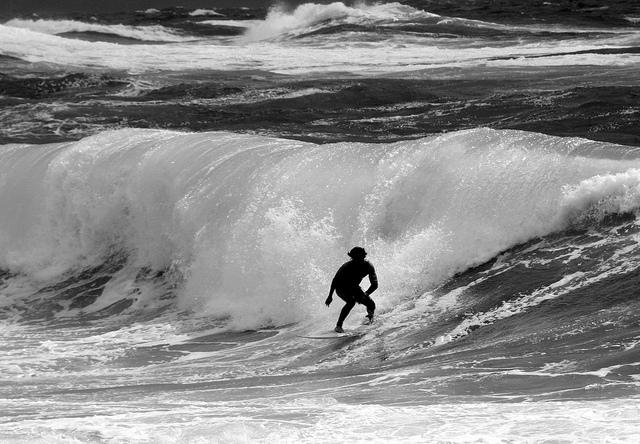How high are the waves?
Short answer required. 12 feet. Can you tell is this is a man or woman?
Keep it brief. No. Is the person wearing a hat?
Give a very brief answer. Yes. 